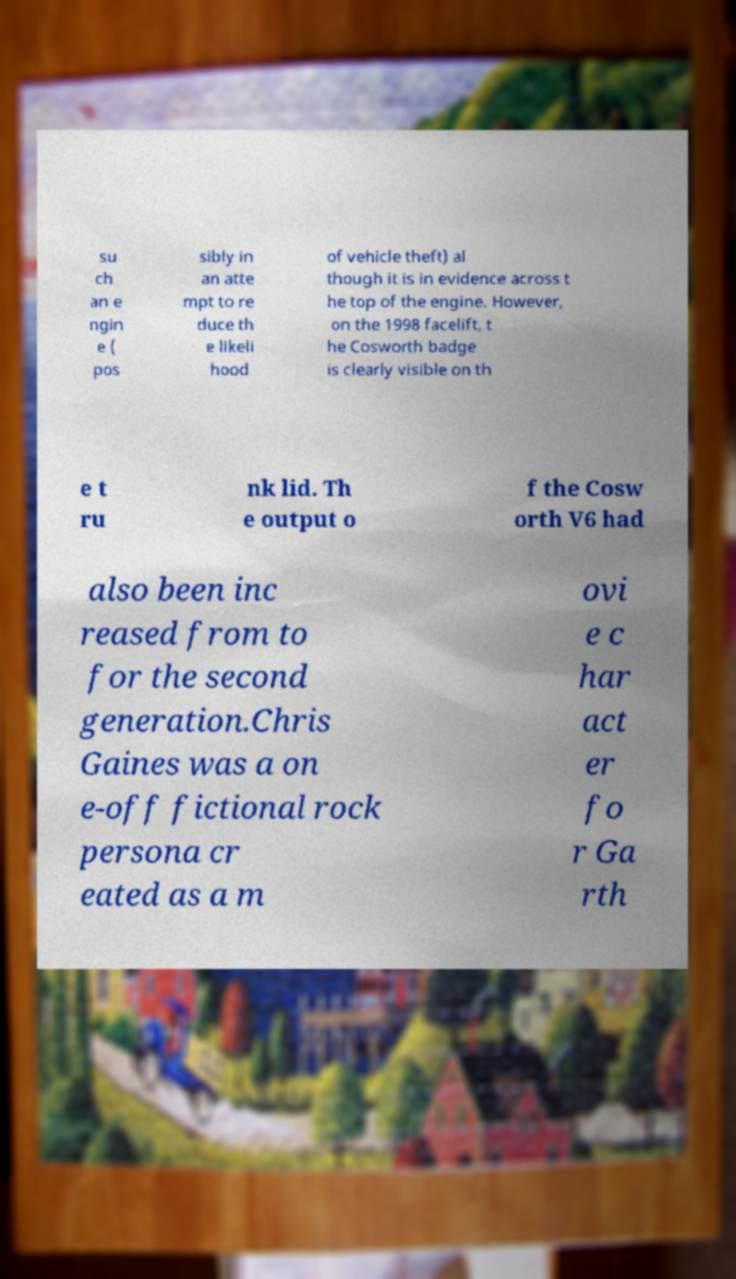Can you accurately transcribe the text from the provided image for me? su ch an e ngin e ( pos sibly in an atte mpt to re duce th e likeli hood of vehicle theft) al though it is in evidence across t he top of the engine. However, on the 1998 facelift, t he Cosworth badge is clearly visible on th e t ru nk lid. Th e output o f the Cosw orth V6 had also been inc reased from to for the second generation.Chris Gaines was a on e-off fictional rock persona cr eated as a m ovi e c har act er fo r Ga rth 